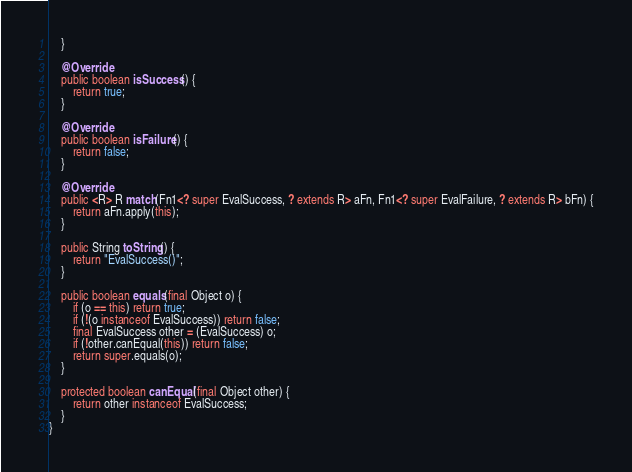Convert code to text. <code><loc_0><loc_0><loc_500><loc_500><_Java_>    }

    @Override
    public boolean isSuccess() {
        return true;
    }

    @Override
    public boolean isFailure() {
        return false;
    }

    @Override
    public <R> R match(Fn1<? super EvalSuccess, ? extends R> aFn, Fn1<? super EvalFailure, ? extends R> bFn) {
        return aFn.apply(this);
    }

    public String toString() {
        return "EvalSuccess()";
    }

    public boolean equals(final Object o) {
        if (o == this) return true;
        if (!(o instanceof EvalSuccess)) return false;
        final EvalSuccess other = (EvalSuccess) o;
        if (!other.canEqual(this)) return false;
        return super.equals(o);
    }

    protected boolean canEqual(final Object other) {
        return other instanceof EvalSuccess;
    }
}
</code> 